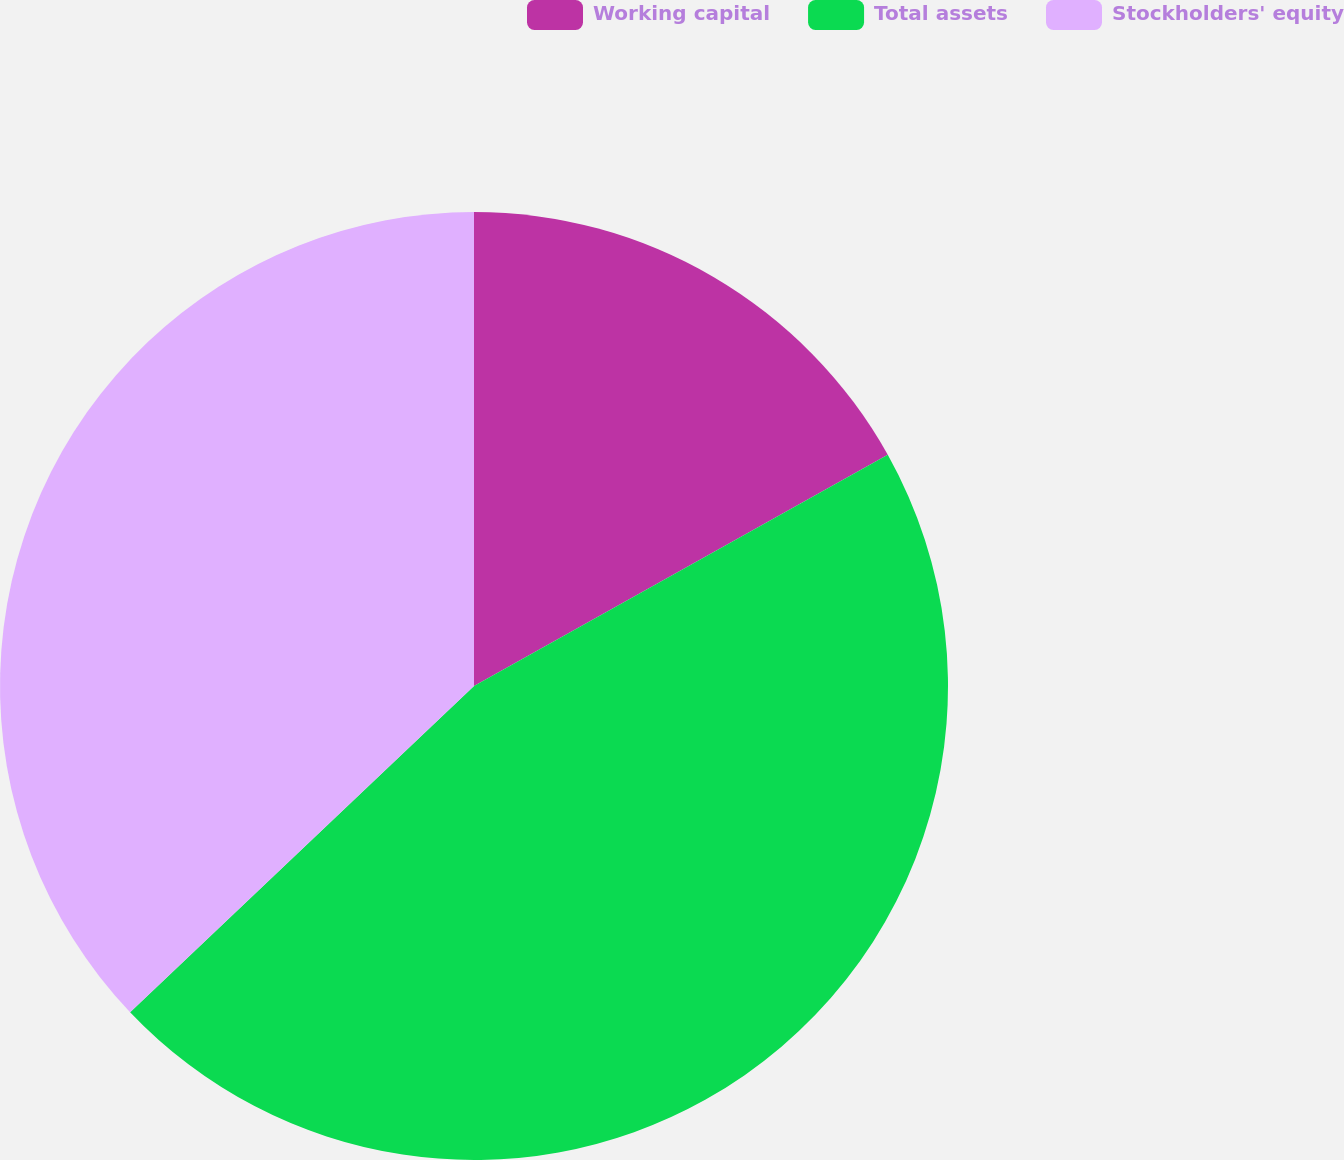Convert chart. <chart><loc_0><loc_0><loc_500><loc_500><pie_chart><fcel>Working capital<fcel>Total assets<fcel>Stockholders' equity<nl><fcel>16.89%<fcel>46.03%<fcel>37.08%<nl></chart> 